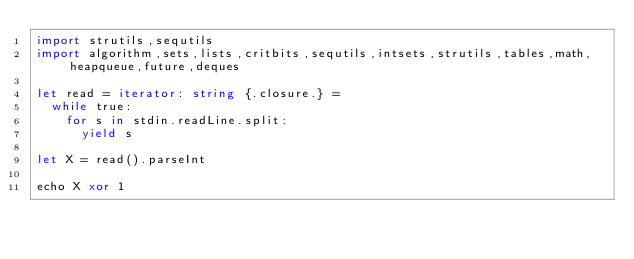Convert code to text. <code><loc_0><loc_0><loc_500><loc_500><_Nim_>import strutils,sequtils
import algorithm,sets,lists,critbits,sequtils,intsets,strutils,tables,math,heapqueue,future,deques

let read = iterator: string {.closure.} =
  while true:
    for s in stdin.readLine.split:
      yield s

let X = read().parseInt

echo X xor 1
</code> 